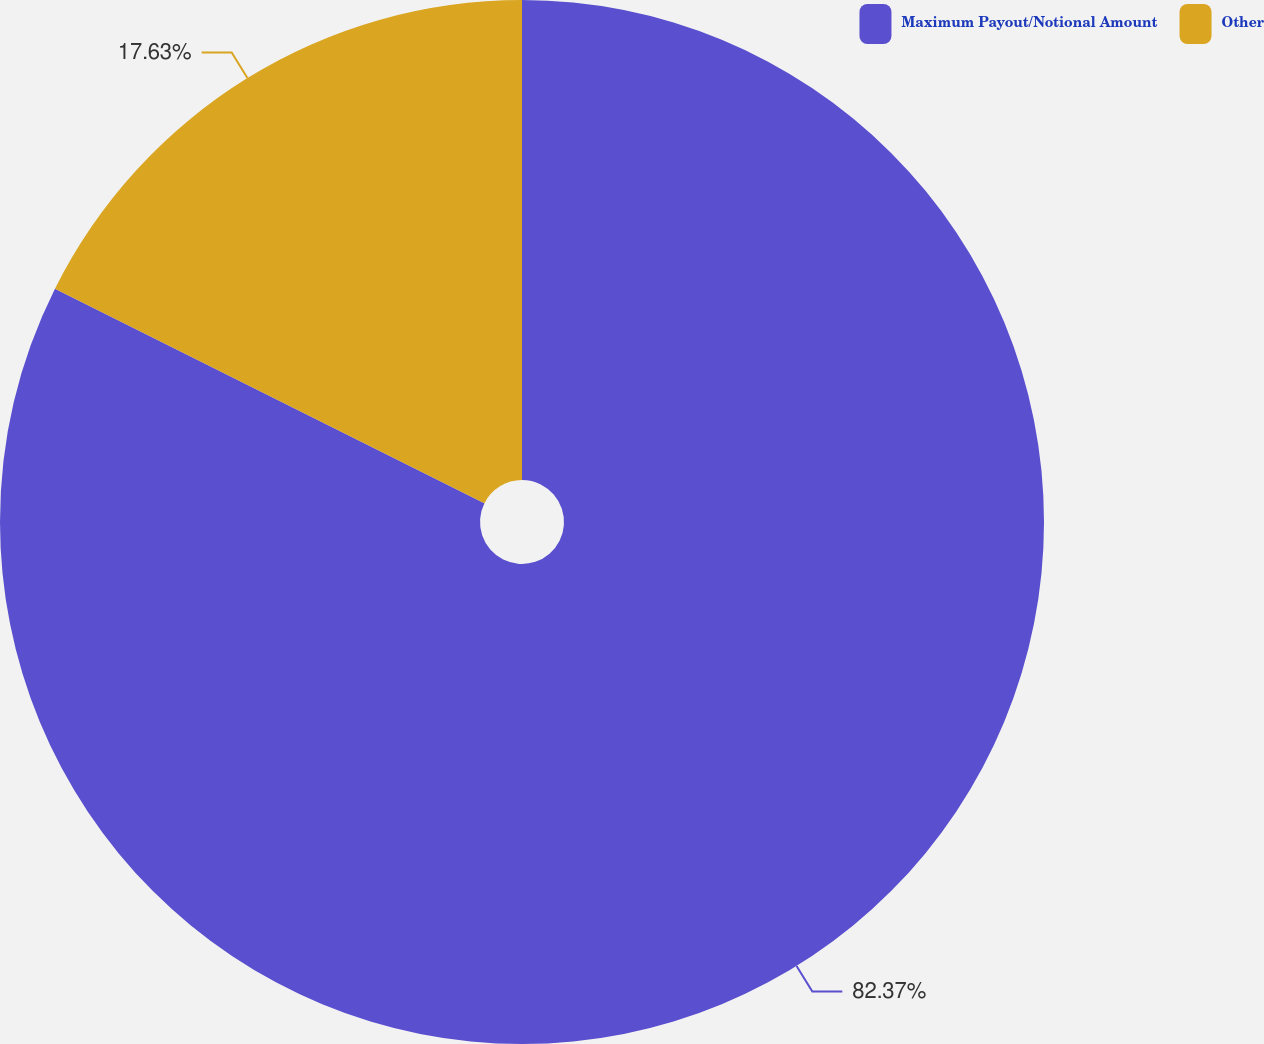Convert chart to OTSL. <chart><loc_0><loc_0><loc_500><loc_500><pie_chart><fcel>Maximum Payout/Notional Amount<fcel>Other<nl><fcel>82.37%<fcel>17.63%<nl></chart> 